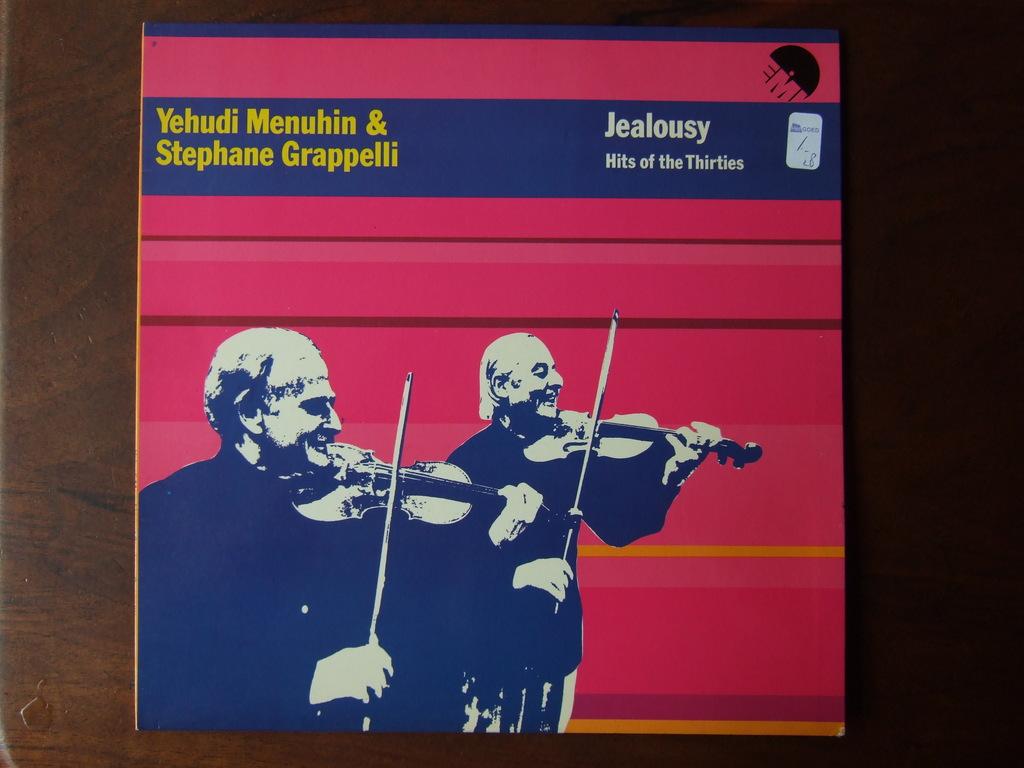Hits of what era is this?
Your answer should be very brief. Thirties. What is the title of the album?
Make the answer very short. Jealousy. 